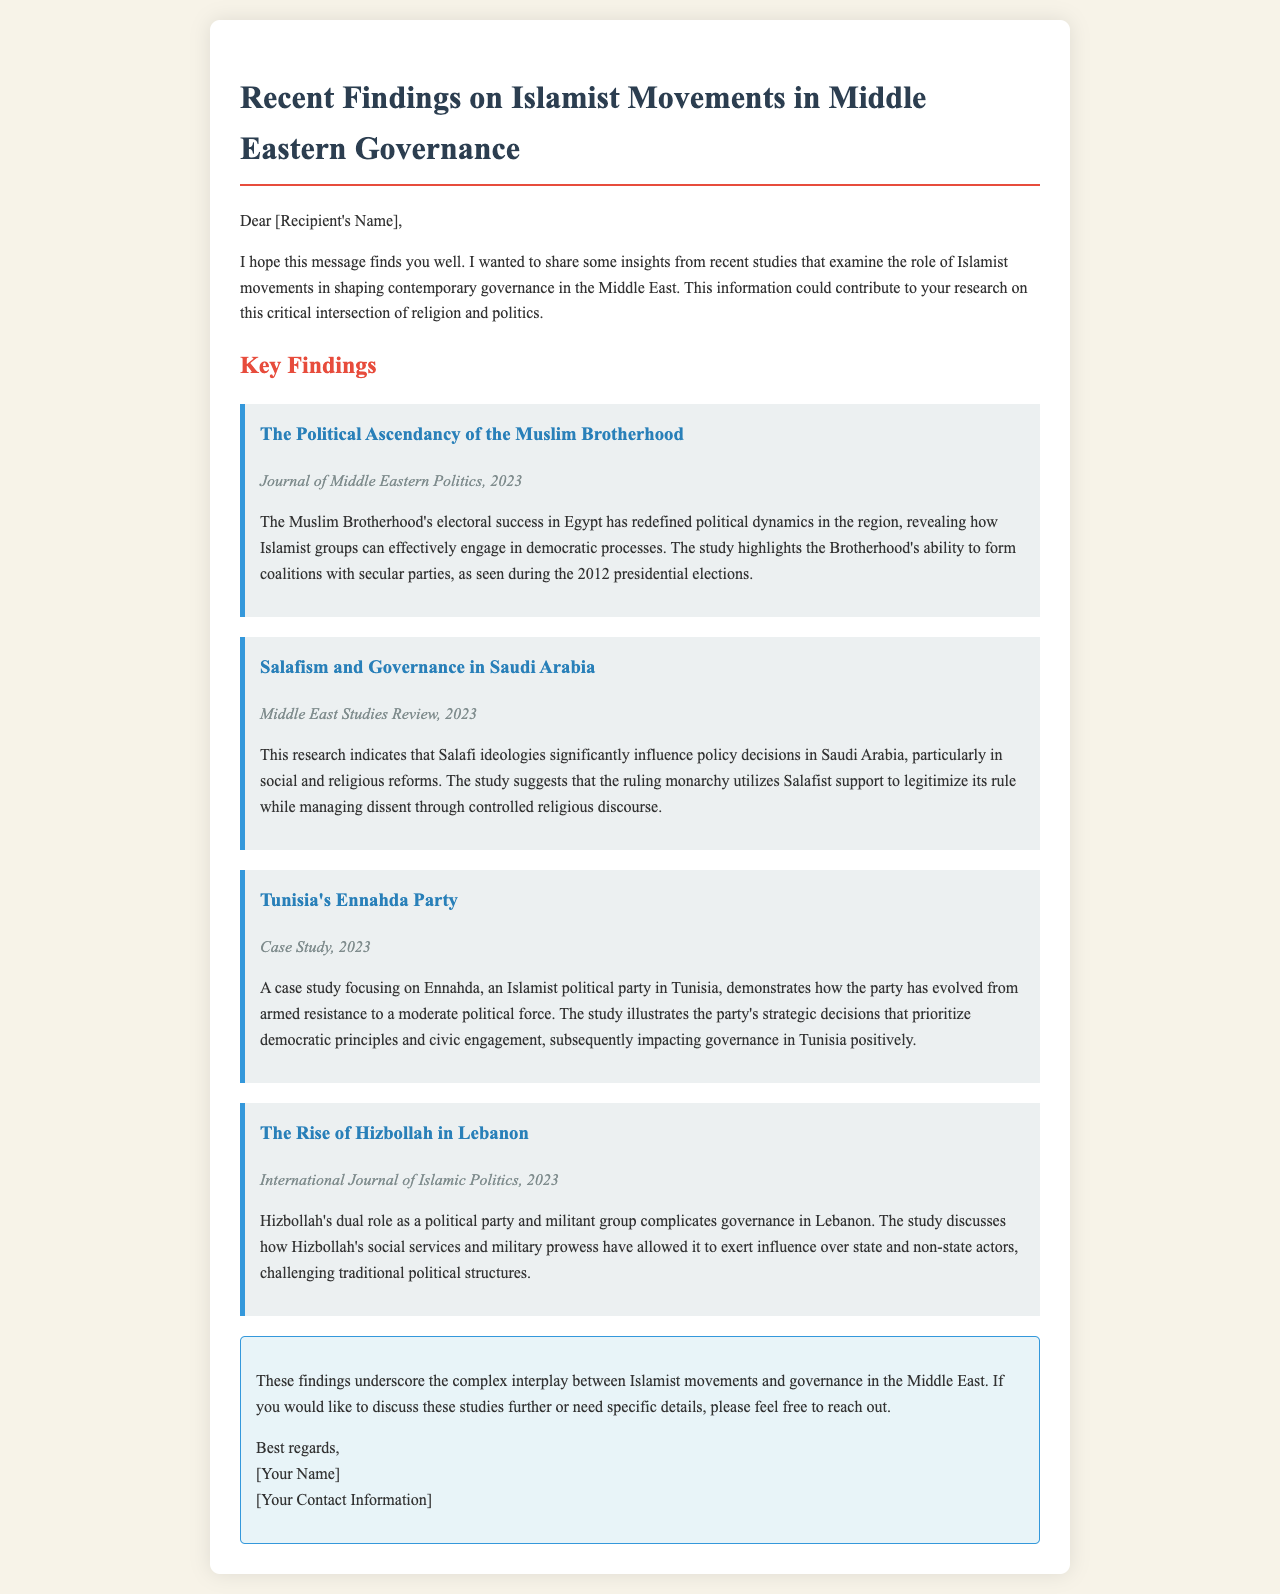What is the title of the first key finding? The first key finding is titled "The Political Ascendancy of the Muslim Brotherhood."
Answer: The Political Ascendancy of the Muslim Brotherhood Which journal published the findings on Salafism in Saudi Arabia? The publication is the "Middle East Studies Review."
Answer: Middle East Studies Review What year was the research on Tunisia's Ennahda Party published? The study focusing on Ennahda was published in 2023.
Answer: 2023 How does Hizbollah influence governance in Lebanon? Hizbollah influences governance through its dual role as a political party and militant group.
Answer: Dual role as a political party and militant group What strategy did the Muslim Brotherhood use during the 2012 presidential elections? The Brotherhood formed coalitions with secular parties during these elections.
Answer: Formed coalitions with secular parties What is the overall theme presented in the conclusion? The conclusion emphasizes the complex interplay between Islamist movements and governance in the Middle East.
Answer: Complex interplay between Islamist movements and governance Which Islamist political party is highlighted in the case study? The highlighted political party is Ennahda.
Answer: Ennahda What is a significant aspect of the study on Salafism and Saudi governance? The study indicates that Salafi ideologies significantly influence policy decisions.
Answer: Salafi ideologies influence policy decisions 